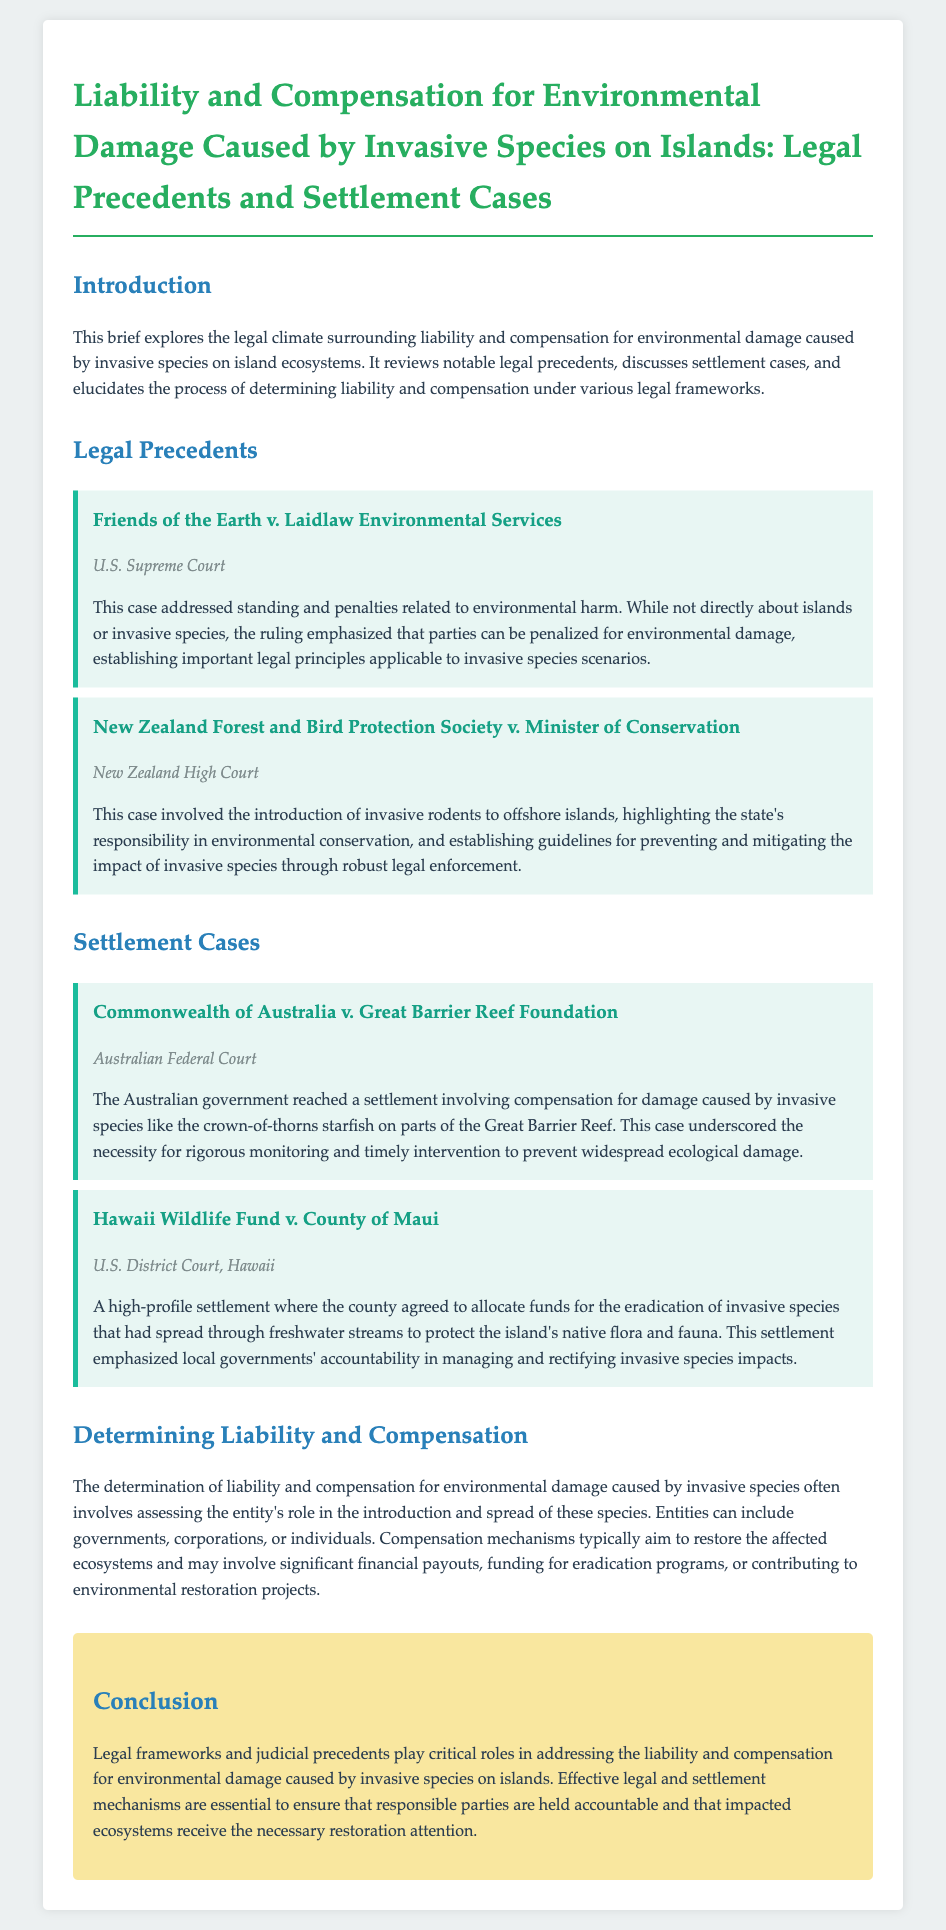What is the title of the legal brief? The title summarizes the main focus of the document, which is Liability and Compensation for Environmental Damage Caused by Invasive Species on Islands.
Answer: Liability and Compensation for Environmental Damage Caused by Invasive Species on Islands: Legal Precedents and Settlement Cases Who was involved in the case Friends of the Earth v. Laidlaw Environmental Services? This case mentions Friends of the Earth as one of the parties involved, addressing penalties related to environmental harm.
Answer: Friends of the Earth What is the jurisdiction of New Zealand Forest and Bird Protection Society v. Minister of Conservation? The jurisdiction indicates where the case was adjudicated, which in this instance is the New Zealand High Court.
Answer: New Zealand High Court Which invasive species is mentioned in the settlement case involving the Commonwealth of Australia? The settlement case focuses on damage caused by the crown-of-thorns starfish affecting parts of the Great Barrier Reef.
Answer: crown-of-thorns starfish What is a key point in the determination of liability and compensation? It highlights the roles of various entities in the introduction and spread of invasive species, influencing how liability is assessed.
Answer: Assessing the entity's role What was a major settlement outcome in Hawaii Wildlife Fund v. County of Maui? The outcome involved the county agreeing to allocate funds specifically for the eradication of invasive species affecting the island's ecosystem.
Answer: Allocate funds for eradication What type of court reviewed the Hawaii Wildlife Fund v. County of Maui case? The document specifies the legal jurisdiction, indicating this was handled at the U.S. District Court, Hawaii.
Answer: U.S. District Court, Hawaii What is emphasized as crucial in the conclusion regarding legal frameworks? The conclusion stresses the necessity for effective mechanisms to hold responsible parties accountable for environmental damage.
Answer: Effective legal and settlement mechanisms What does the brief suggest is often involved in compensation mechanisms? It implies that compensation mechanisms frequently aim to restore impacted ecosystems through various means, including funding.
Answer: Restoration of ecosystems 